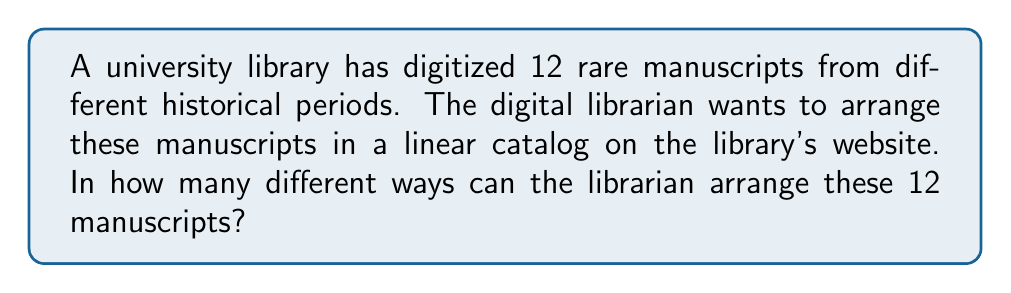Could you help me with this problem? To solve this problem, we need to consider the following:

1. We have 12 distinct manuscripts.
2. We need to arrange all of them in a linear order.
3. The order matters (e.g., manuscript A followed by manuscript B is different from manuscript B followed by manuscript A).
4. Each manuscript can only be used once in the arrangement.

This scenario is a perfect example of a permutation problem. Specifically, it's a permutation of all 12 manuscripts, where we're arranging all of them without repetition.

The formula for permutations of n distinct objects is:

$$P(n) = n!$$

Where $n!$ represents the factorial of $n$.

In this case, $n = 12$, so we calculate:

$$P(12) = 12!$$

Expanding this:

$$\begin{align*}
12! &= 12 \times 11 \times 10 \times 9 \times 8 \times 7 \times 6 \times 5 \times 4 \times 3 \times 2 \times 1 \\
&= 479,001,600
\end{align*}$$

Therefore, the digital librarian can arrange the 12 rare manuscripts in 479,001,600 different ways in the online catalog.
Answer: $479,001,600$ ways 